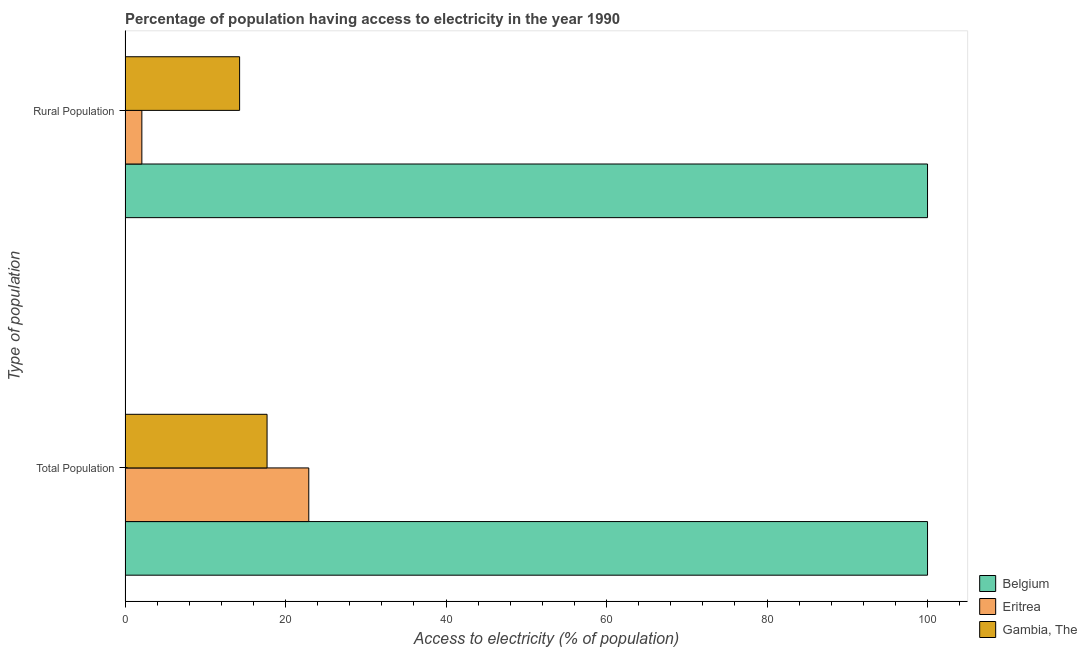How many groups of bars are there?
Provide a short and direct response. 2. How many bars are there on the 1st tick from the top?
Make the answer very short. 3. What is the label of the 1st group of bars from the top?
Your response must be concise. Rural Population. What is the percentage of rural population having access to electricity in Eritrea?
Provide a succinct answer. 2.1. In which country was the percentage of rural population having access to electricity maximum?
Provide a short and direct response. Belgium. In which country was the percentage of population having access to electricity minimum?
Offer a very short reply. Gambia, The. What is the total percentage of population having access to electricity in the graph?
Offer a terse response. 140.6. What is the difference between the percentage of population having access to electricity in Eritrea and that in Belgium?
Make the answer very short. -77.1. What is the difference between the percentage of population having access to electricity in Eritrea and the percentage of rural population having access to electricity in Gambia, The?
Offer a very short reply. 8.62. What is the average percentage of rural population having access to electricity per country?
Ensure brevity in your answer.  38.79. What is the difference between the percentage of population having access to electricity and percentage of rural population having access to electricity in Eritrea?
Your answer should be very brief. 20.8. In how many countries, is the percentage of population having access to electricity greater than 16 %?
Your answer should be compact. 3. What is the ratio of the percentage of population having access to electricity in Belgium to that in Eritrea?
Provide a short and direct response. 4.37. In how many countries, is the percentage of rural population having access to electricity greater than the average percentage of rural population having access to electricity taken over all countries?
Offer a terse response. 1. What does the 3rd bar from the bottom in Rural Population represents?
Ensure brevity in your answer.  Gambia, The. Are all the bars in the graph horizontal?
Your answer should be compact. Yes. How many countries are there in the graph?
Give a very brief answer. 3. What is the difference between two consecutive major ticks on the X-axis?
Provide a succinct answer. 20. Are the values on the major ticks of X-axis written in scientific E-notation?
Your answer should be very brief. No. Does the graph contain any zero values?
Your answer should be compact. No. Where does the legend appear in the graph?
Make the answer very short. Bottom right. How many legend labels are there?
Offer a very short reply. 3. How are the legend labels stacked?
Keep it short and to the point. Vertical. What is the title of the graph?
Offer a terse response. Percentage of population having access to electricity in the year 1990. Does "Ecuador" appear as one of the legend labels in the graph?
Ensure brevity in your answer.  No. What is the label or title of the X-axis?
Provide a short and direct response. Access to electricity (% of population). What is the label or title of the Y-axis?
Your response must be concise. Type of population. What is the Access to electricity (% of population) of Belgium in Total Population?
Ensure brevity in your answer.  100. What is the Access to electricity (% of population) in Eritrea in Total Population?
Provide a short and direct response. 22.9. What is the Access to electricity (% of population) in Belgium in Rural Population?
Provide a succinct answer. 100. What is the Access to electricity (% of population) of Gambia, The in Rural Population?
Offer a very short reply. 14.28. Across all Type of population, what is the maximum Access to electricity (% of population) of Eritrea?
Your response must be concise. 22.9. Across all Type of population, what is the minimum Access to electricity (% of population) of Belgium?
Make the answer very short. 100. Across all Type of population, what is the minimum Access to electricity (% of population) of Eritrea?
Keep it short and to the point. 2.1. Across all Type of population, what is the minimum Access to electricity (% of population) in Gambia, The?
Provide a short and direct response. 14.28. What is the total Access to electricity (% of population) in Eritrea in the graph?
Give a very brief answer. 25. What is the total Access to electricity (% of population) of Gambia, The in the graph?
Your answer should be very brief. 31.98. What is the difference between the Access to electricity (% of population) in Belgium in Total Population and that in Rural Population?
Make the answer very short. 0. What is the difference between the Access to electricity (% of population) of Eritrea in Total Population and that in Rural Population?
Your response must be concise. 20.8. What is the difference between the Access to electricity (% of population) of Gambia, The in Total Population and that in Rural Population?
Your answer should be compact. 3.42. What is the difference between the Access to electricity (% of population) in Belgium in Total Population and the Access to electricity (% of population) in Eritrea in Rural Population?
Make the answer very short. 97.9. What is the difference between the Access to electricity (% of population) of Belgium in Total Population and the Access to electricity (% of population) of Gambia, The in Rural Population?
Offer a terse response. 85.72. What is the difference between the Access to electricity (% of population) of Eritrea in Total Population and the Access to electricity (% of population) of Gambia, The in Rural Population?
Give a very brief answer. 8.62. What is the average Access to electricity (% of population) in Belgium per Type of population?
Provide a short and direct response. 100. What is the average Access to electricity (% of population) in Eritrea per Type of population?
Ensure brevity in your answer.  12.5. What is the average Access to electricity (% of population) of Gambia, The per Type of population?
Ensure brevity in your answer.  15.99. What is the difference between the Access to electricity (% of population) in Belgium and Access to electricity (% of population) in Eritrea in Total Population?
Offer a terse response. 77.1. What is the difference between the Access to electricity (% of population) in Belgium and Access to electricity (% of population) in Gambia, The in Total Population?
Make the answer very short. 82.3. What is the difference between the Access to electricity (% of population) of Eritrea and Access to electricity (% of population) of Gambia, The in Total Population?
Ensure brevity in your answer.  5.2. What is the difference between the Access to electricity (% of population) in Belgium and Access to electricity (% of population) in Eritrea in Rural Population?
Offer a very short reply. 97.9. What is the difference between the Access to electricity (% of population) in Belgium and Access to electricity (% of population) in Gambia, The in Rural Population?
Give a very brief answer. 85.72. What is the difference between the Access to electricity (% of population) in Eritrea and Access to electricity (% of population) in Gambia, The in Rural Population?
Offer a terse response. -12.18. What is the ratio of the Access to electricity (% of population) in Eritrea in Total Population to that in Rural Population?
Your answer should be very brief. 10.9. What is the ratio of the Access to electricity (% of population) in Gambia, The in Total Population to that in Rural Population?
Give a very brief answer. 1.24. What is the difference between the highest and the second highest Access to electricity (% of population) of Belgium?
Your response must be concise. 0. What is the difference between the highest and the second highest Access to electricity (% of population) of Eritrea?
Offer a very short reply. 20.8. What is the difference between the highest and the second highest Access to electricity (% of population) of Gambia, The?
Provide a succinct answer. 3.42. What is the difference between the highest and the lowest Access to electricity (% of population) in Eritrea?
Keep it short and to the point. 20.8. What is the difference between the highest and the lowest Access to electricity (% of population) in Gambia, The?
Give a very brief answer. 3.42. 